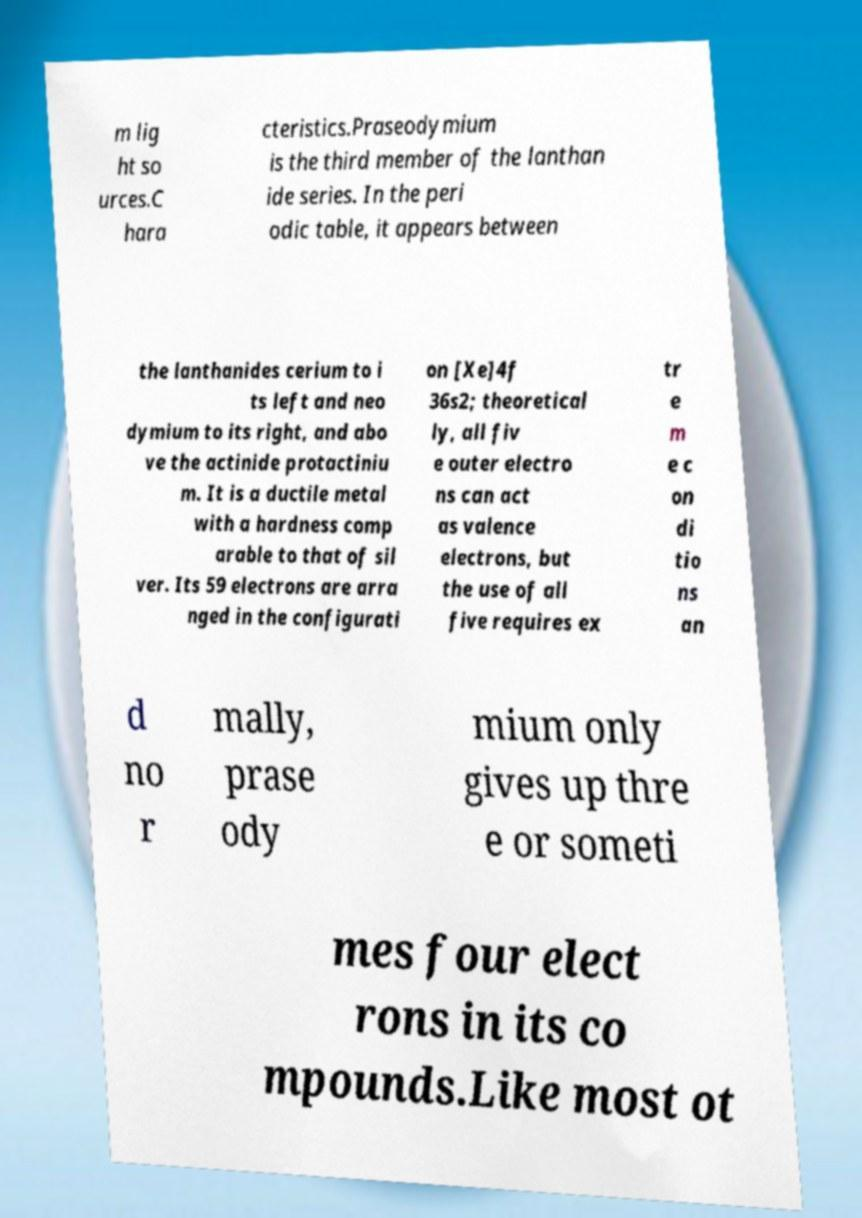There's text embedded in this image that I need extracted. Can you transcribe it verbatim? m lig ht so urces.C hara cteristics.Praseodymium is the third member of the lanthan ide series. In the peri odic table, it appears between the lanthanides cerium to i ts left and neo dymium to its right, and abo ve the actinide protactiniu m. It is a ductile metal with a hardness comp arable to that of sil ver. Its 59 electrons are arra nged in the configurati on [Xe]4f 36s2; theoretical ly, all fiv e outer electro ns can act as valence electrons, but the use of all five requires ex tr e m e c on di tio ns an d no r mally, prase ody mium only gives up thre e or someti mes four elect rons in its co mpounds.Like most ot 